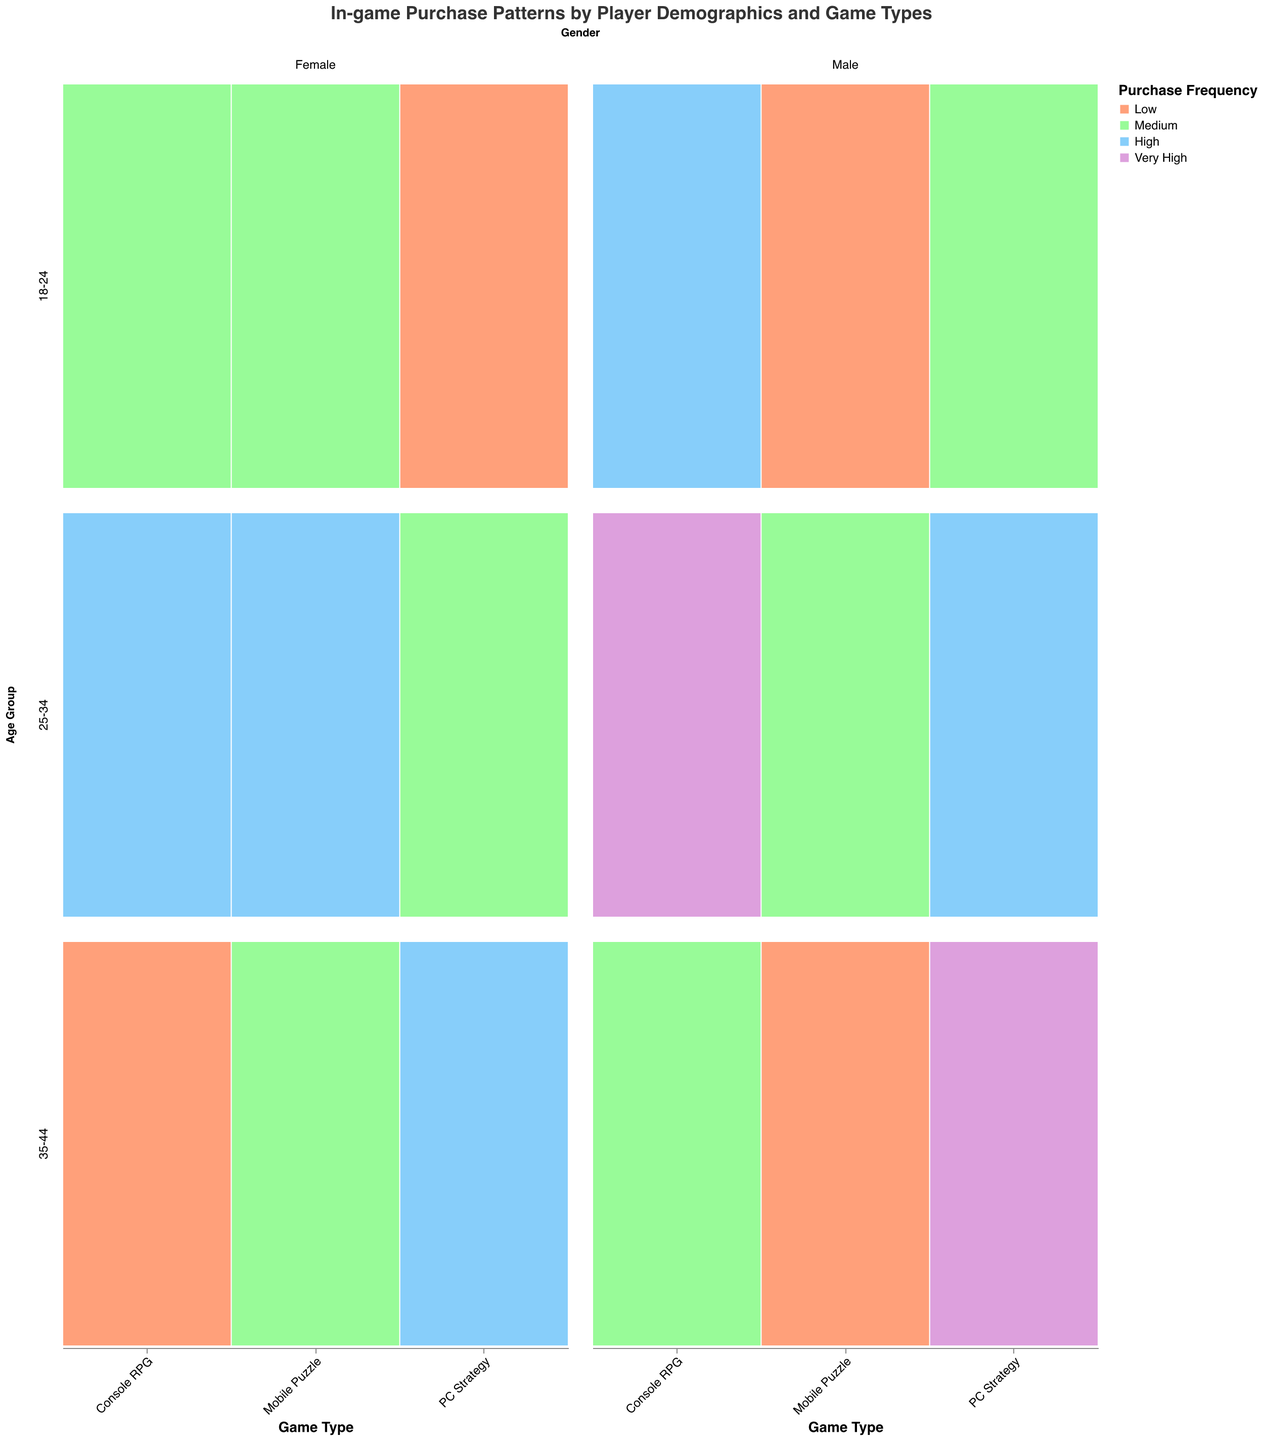What's the title of the figure? The title is usually displayed at the top of the figure and summarizes the content it's portraying.
Answer: In-game Purchase Patterns by Player Demographics and Game Types Which Gender has higher purchase frequency in the 25-34 age group for Console RPG? Look at the '25-34' row and 'Console RPG' column, then compare the color segments within the Male and Female columns. The Female column has a larger bar at 'High', whereas Male has 'Very High'.
Answer: Male In the Mobile Puzzle game, how does the in-game purchase frequency for females change as age increases? Look at the Female column in the Mobile Puzzle game type for each age group row. Observe the colors: '18-24' is Medium, '25-34' is High, '35-44' is Medium.
Answer: Medium to High to Medium Compare the purchase frequencies between male players aged 18-24 for PC Strategy and Console RPG games. Which one is higher? Go to the '18-24' row and compare the color segments within the Male columns for PC Strategy and Console RPG. PC Strategy is Medium and Console RPG is High.
Answer: Console RPG Which game type has the highest purchase frequency in the 35-44 age group for male players? Look at the '35-44' row and go over the Male columns for each game type. Identify the highest color (Very High) and its respective game type (PC Strategy).
Answer: PC Strategy In PC Strategy games, do males or females aged 25-34 show higher purchase frequency? Look at the '25-34' row in the PC Strategy column and compare the sizes of the segments for Male and Female. Males are High, Females are Medium.
Answer: Male What's the purchase frequency trend for female players in Console RPG games as they age from 18-24 to 35-44? Look at the Female column in Console RPG for each age group. Observe the colors: '18-24' is Medium, '25-34' is High, '35-44' is Low.
Answer: Medium to High to Low Which age group and gender combination shows Medium purchase frequency for Mobile Puzzle games? Scan the Mobile Puzzle columns for the color corresponding to Medium. Both '18-24' Female and '35-44' Female match this description.
Answer: 18-24 Female and 35-44 Female How many different purchase frequency categories are used in the plot, and what are they? Look at the color legend to identify the purchase frequency categories. There are four color segments, each representing different purchase frequencies: Low, Medium, High, Very High.
Answer: Four - Low, Medium, High, Very High In PC Strategy games, who has higher purchase frequency: males aged 35-44 or males aged 18-24? Compare the Male columns in PC Strategy for '35-44' (Very High) and '18-24' (Medium) age groups.
Answer: Males aged 35-44 